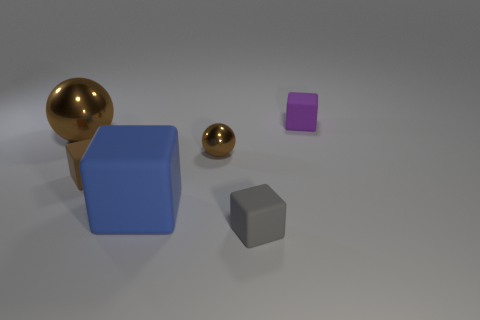What number of other things are there of the same shape as the small gray object?
Give a very brief answer. 3. Are there the same number of gray things that are behind the small gray block and tiny rubber cubes that are behind the large blue cube?
Provide a short and direct response. No. What is the gray cube made of?
Make the answer very short. Rubber. What material is the brown sphere that is to the left of the tiny sphere?
Your answer should be very brief. Metal. Is there anything else that has the same material as the tiny purple block?
Offer a very short reply. Yes. Is the number of tiny things on the right side of the large cube greater than the number of small gray blocks?
Your response must be concise. Yes. Are there any rubber blocks on the right side of the brown metallic object on the right side of the ball that is to the left of the brown block?
Offer a terse response. Yes. There is a brown matte block; are there any large cubes behind it?
Give a very brief answer. No. What number of large matte blocks have the same color as the large shiny object?
Your answer should be compact. 0. There is another sphere that is made of the same material as the big brown sphere; what size is it?
Your answer should be very brief. Small. 